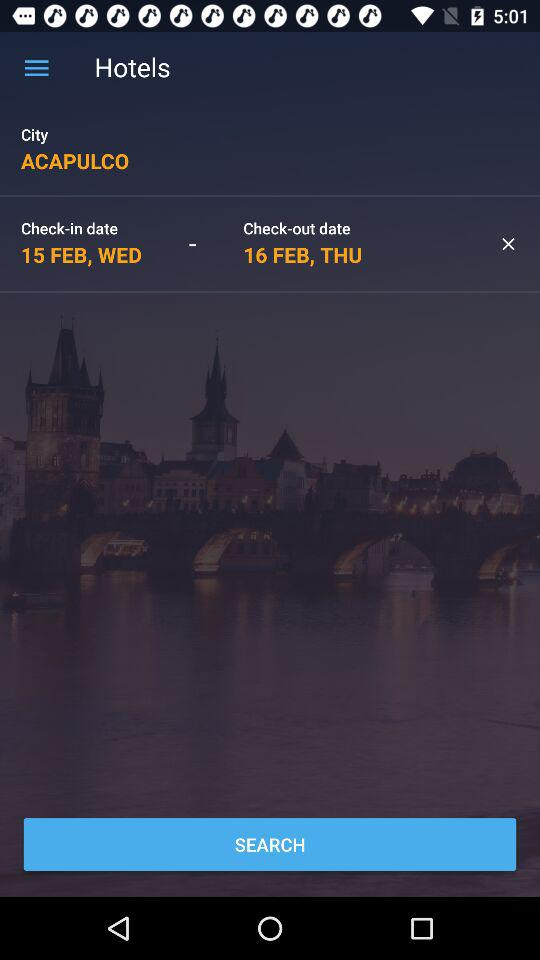What is the check-out date? The check-out date is Thursday, February 16. 